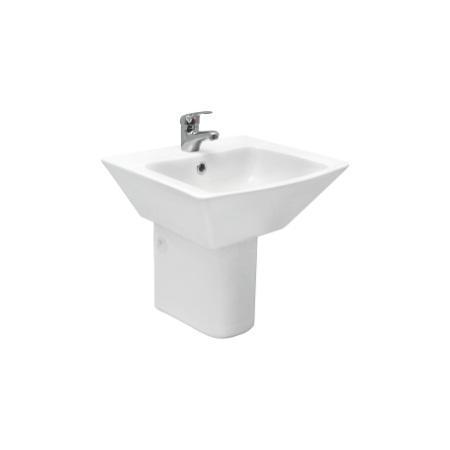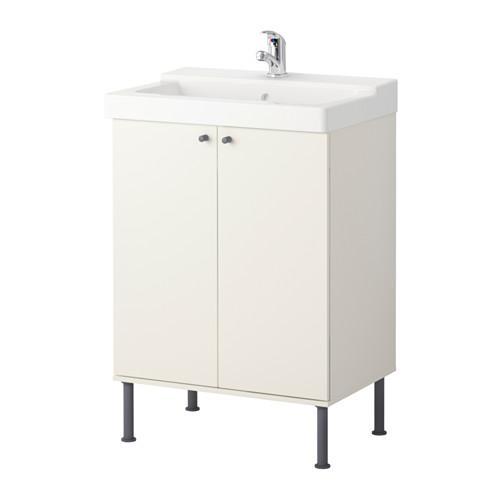The first image is the image on the left, the second image is the image on the right. For the images displayed, is the sentence "The right-hand sink is rectangular rather than rounded." factually correct? Answer yes or no. Yes. 